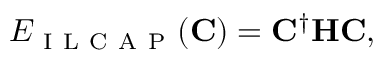Convert formula to latex. <formula><loc_0><loc_0><loc_500><loc_500>E _ { I L C A P } ( C ) = C ^ { \dagger } H C ,</formula> 